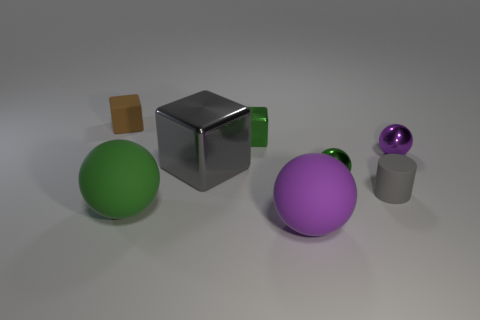Subtract all green matte balls. How many balls are left? 3 Subtract all cyan spheres. Subtract all brown blocks. How many spheres are left? 4 Add 1 big gray metallic objects. How many objects exist? 9 Subtract all cylinders. How many objects are left? 7 Subtract 0 red balls. How many objects are left? 8 Subtract all small cyan things. Subtract all small purple things. How many objects are left? 7 Add 5 tiny balls. How many tiny balls are left? 7 Add 5 big gray metallic things. How many big gray metallic things exist? 6 